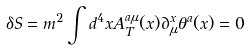<formula> <loc_0><loc_0><loc_500><loc_500>\delta S = m ^ { 2 } \int d ^ { 4 } x A _ { T } ^ { a \mu } ( x ) \partial _ { \mu } ^ { x } \theta ^ { a } ( x ) = 0</formula> 